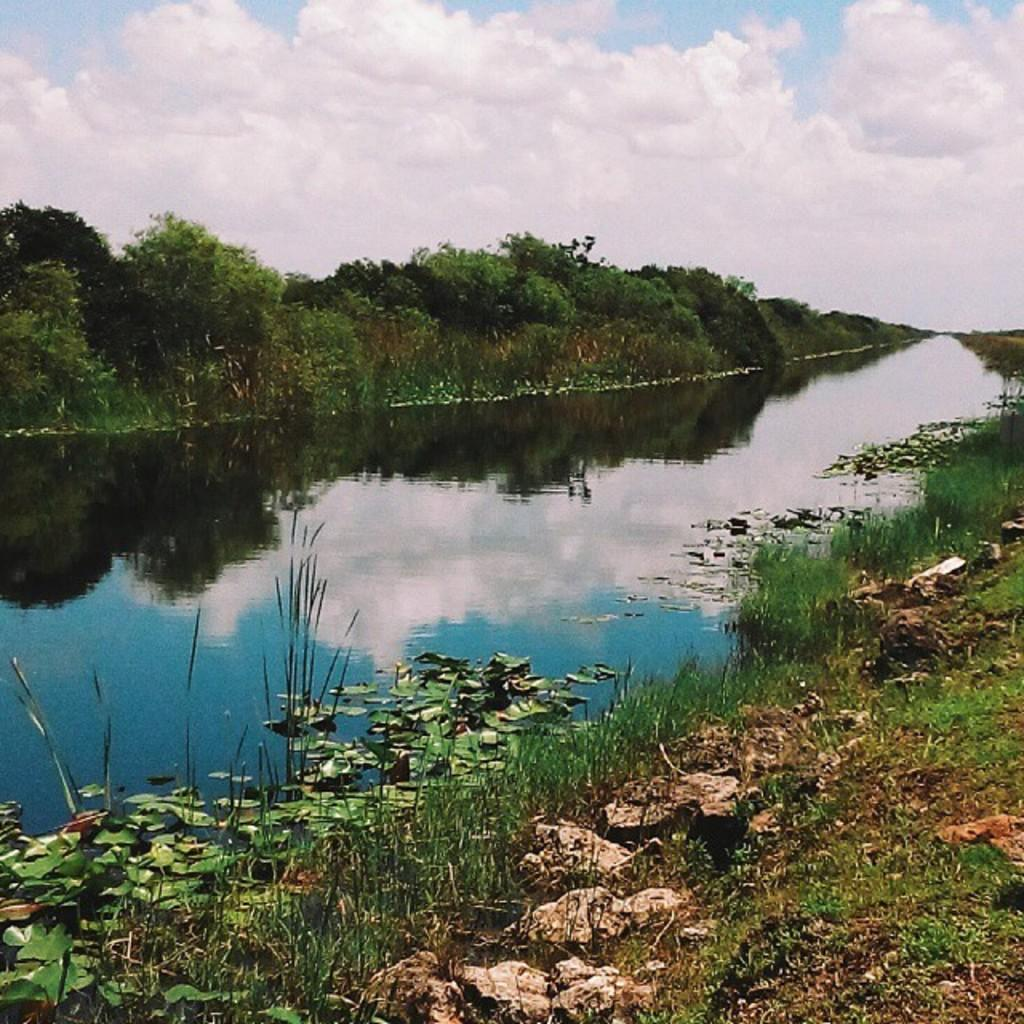What type of vegetation is present in the image? There is grass in the image. What else can be seen besides grass in the image? There is water and trees visible in the image. What is visible in the background of the image? The sky is visible in the image, and there are clouds present. Can you tell me how many beetles are crawling on the grass in the image? There are no beetles present in the image; it only features grass, water, trees, and the sky. What level of difficulty is the water in the image? The image does not provide information about the difficulty level of the water; it simply shows water in the scene. 